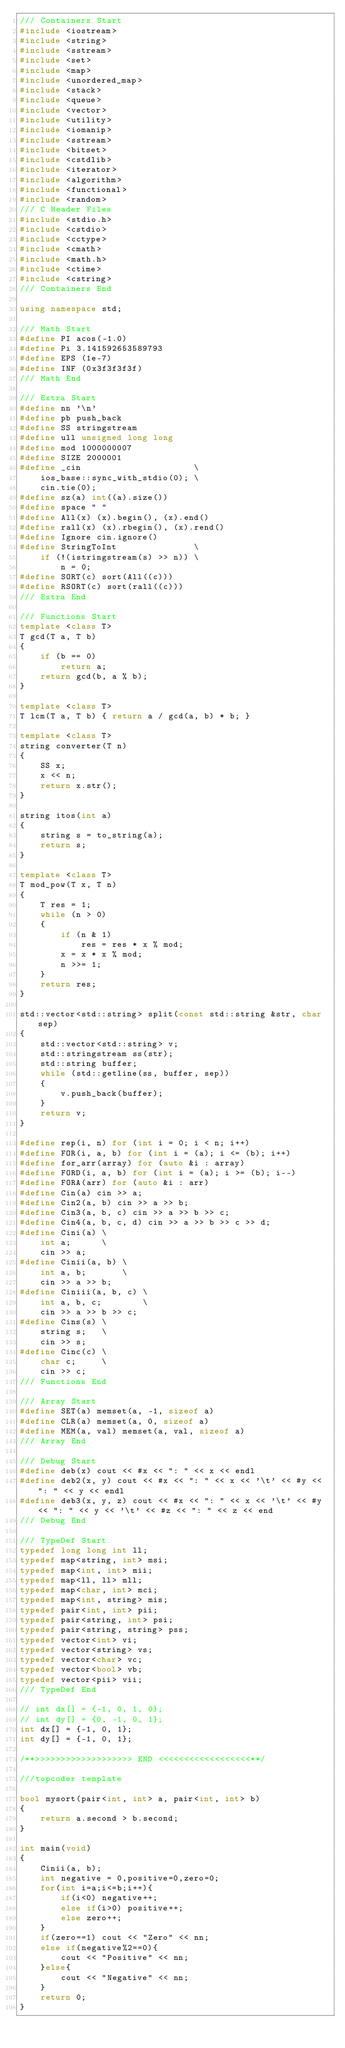<code> <loc_0><loc_0><loc_500><loc_500><_C++_>/// Containers Start
#include <iostream>
#include <string>
#include <sstream>
#include <set>
#include <map>
#include <unordered_map>
#include <stack>
#include <queue>
#include <vector>
#include <utility>
#include <iomanip>
#include <sstream>
#include <bitset>
#include <cstdlib>
#include <iterator>
#include <algorithm>
#include <functional>
#include <random>
/// C Header Files
#include <stdio.h>
#include <cstdio>
#include <cctype>
#include <cmath>
#include <math.h>
#include <ctime>
#include <cstring>
/// Containers End

using namespace std;

/// Math Start
#define PI acos(-1.0)
#define Pi 3.141592653589793
#define EPS (1e-7)
#define INF (0x3f3f3f3f)
/// Math End

/// Extra Start
#define nn '\n'
#define pb push_back
#define SS stringstream
#define ull unsigned long long
#define mod 1000000007
#define SIZE 2000001
#define _cin                      \
    ios_base::sync_with_stdio(0); \
    cin.tie(0);
#define sz(a) int((a).size())
#define space " "
#define All(x) (x).begin(), (x).end()
#define rall(x) (x).rbegin(), (x).rend()
#define Ignore cin.ignore()
#define StringToInt               \
    if (!(istringstream(s) >> n)) \
        n = 0;
#define SORT(c) sort(All((c)))
#define RSORT(c) sort(rall((c)))
/// Extra End

/// Functions Start
template <class T>
T gcd(T a, T b)
{
    if (b == 0)
        return a;
    return gcd(b, a % b);
}

template <class T>
T lcm(T a, T b) { return a / gcd(a, b) * b; }

template <class T>
string converter(T n)
{
    SS x;
    x << n;
    return x.str();
}

string itos(int a)
{
    string s = to_string(a);
    return s;
}

template <class T>
T mod_pow(T x, T n)
{
    T res = 1;
    while (n > 0)
    {
        if (n & 1)
            res = res * x % mod;
        x = x * x % mod;
        n >>= 1;
    }
    return res;
}

std::vector<std::string> split(const std::string &str, char sep)
{
    std::vector<std::string> v;
    std::stringstream ss(str);
    std::string buffer;
    while (std::getline(ss, buffer, sep))
    {
        v.push_back(buffer);
    }
    return v;
}

#define rep(i, n) for (int i = 0; i < n; i++)
#define FOR(i, a, b) for (int i = (a); i <= (b); i++)
#define for_arr(array) for (auto &i : array)
#define FORD(i, a, b) for (int i = (a); i >= (b); i--)
#define FORA(arr) for (auto &i : arr)
#define Cin(a) cin >> a;
#define Cin2(a, b) cin >> a >> b;
#define Cin3(a, b, c) cin >> a >> b >> c;
#define Cin4(a, b, c, d) cin >> a >> b >> c >> d;
#define Cini(a) \
    int a;      \
    cin >> a;
#define Cinii(a, b) \
    int a, b;       \
    cin >> a >> b;
#define Ciniii(a, b, c) \
    int a, b, c;        \
    cin >> a >> b >> c;
#define Cins(s) \
    string s;   \
    cin >> s;
#define Cinc(c) \
    char c;     \
    cin >> c;
/// Functions End

/// Array Start
#define SET(a) memset(a, -1, sizeof a)
#define CLR(a) memset(a, 0, sizeof a)
#define MEM(a, val) memset(a, val, sizeof a)
/// Array End

/// Debug Start
#define deb(x) cout << #x << ": " << x << endl
#define deb2(x, y) cout << #x << ": " << x << '\t' << #y << ": " << y << endl
#define deb3(x, y, z) cout << #x << ": " << x << '\t' << #y << ": " << y << '\t' << #z << ": " << z << end
/// Debug End

/// TypeDef Start
typedef long long int ll;
typedef map<string, int> msi;
typedef map<int, int> mii;
typedef map<ll, ll> mll;
typedef map<char, int> mci;
typedef map<int, string> mis;
typedef pair<int, int> pii;
typedef pair<string, int> psi;
typedef pair<string, string> pss;
typedef vector<int> vi;
typedef vector<string> vs;
typedef vector<char> vc;
typedef vector<bool> vb;
typedef vector<pii> vii;
/// TypeDef End

// int dx[] = {-1, 0, 1, 0};
// int dy[] = {0, -1, 0, 1};
int dx[] = {-1, 0, 1};
int dy[] = {-1, 0, 1};

/**>>>>>>>>>>>>>>>>>>> END <<<<<<<<<<<<<<<<<<**/

///topcoder template

bool mysort(pair<int, int> a, pair<int, int> b)
{
    return a.second > b.second;
}

int main(void)
{
    Cinii(a, b);
    int negative = 0,positive=0,zero=0;
    for(int i=a;i<=b;i++){
        if(i<0) negative++;
        else if(i>0) positive++;
        else zero++;
    }
    if(zero==1) cout << "Zero" << nn;
    else if(negative%2==0){
        cout << "Positive" << nn;
    }else{
        cout << "Negative" << nn;
    }
    return 0;
}
</code> 